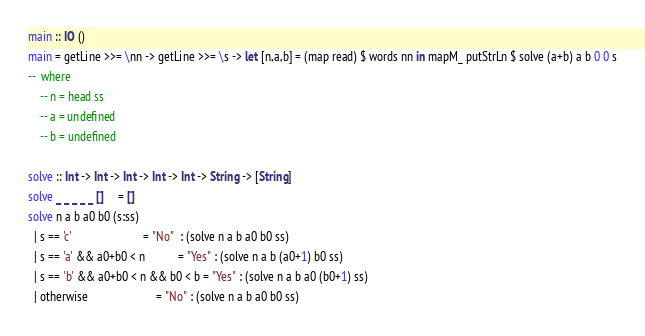<code> <loc_0><loc_0><loc_500><loc_500><_Haskell_>main :: IO ()
main = getLine >>= \nn -> getLine >>= \s -> let [n,a,b] = (map read) $ words nn in mapM_ putStrLn $ solve (a+b) a b 0 0 s
--  where
    -- n = head ss
    -- a = undefined
    -- b = undefined

solve :: Int -> Int -> Int -> Int -> Int -> String -> [String]
solve _ _ _ _ _ []     = []
solve n a b a0 b0 (s:ss)
  | s == 'c'                        = "No"  : (solve n a b a0 b0 ss)
  | s == 'a' && a0+b0 < n           = "Yes" : (solve n a b (a0+1) b0 ss)
  | s == 'b' && a0+b0 < n && b0 < b = "Yes" : (solve n a b a0 (b0+1) ss)
  | otherwise                       = "No" : (solve n a b a0 b0 ss)</code> 